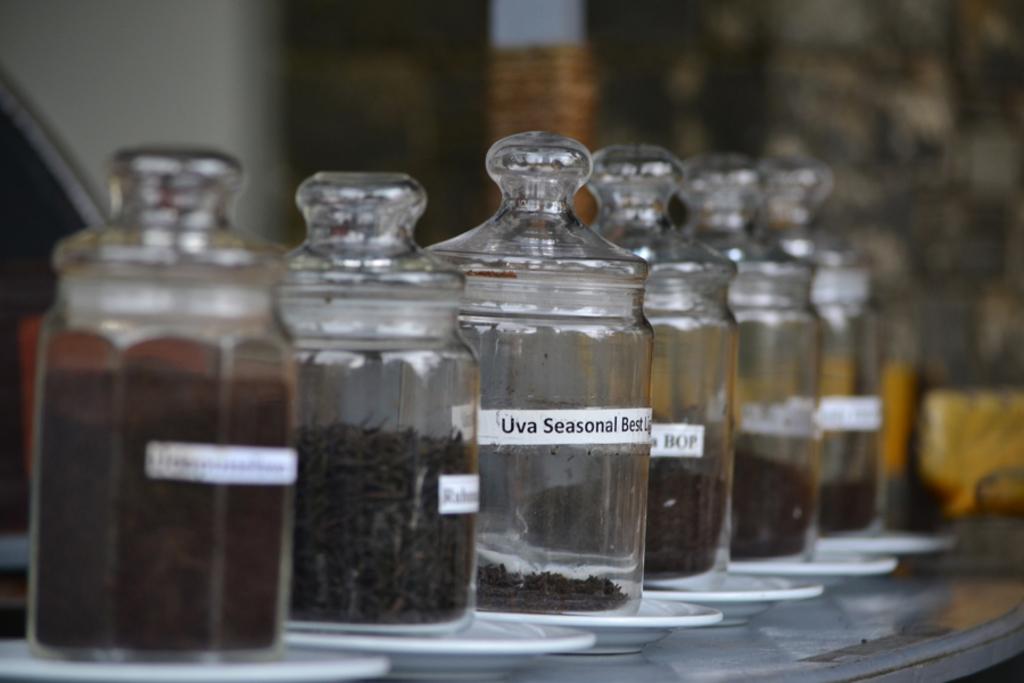What seasonal best?
Provide a succinct answer. Uva. 